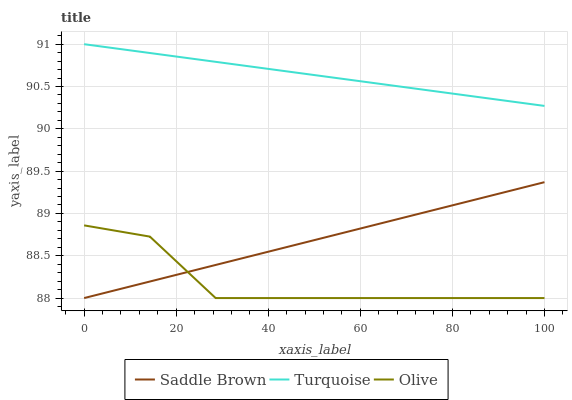Does Saddle Brown have the minimum area under the curve?
Answer yes or no. No. Does Saddle Brown have the maximum area under the curve?
Answer yes or no. No. Is Turquoise the smoothest?
Answer yes or no. No. Is Turquoise the roughest?
Answer yes or no. No. Does Turquoise have the lowest value?
Answer yes or no. No. Does Saddle Brown have the highest value?
Answer yes or no. No. Is Olive less than Turquoise?
Answer yes or no. Yes. Is Turquoise greater than Saddle Brown?
Answer yes or no. Yes. Does Olive intersect Turquoise?
Answer yes or no. No. 